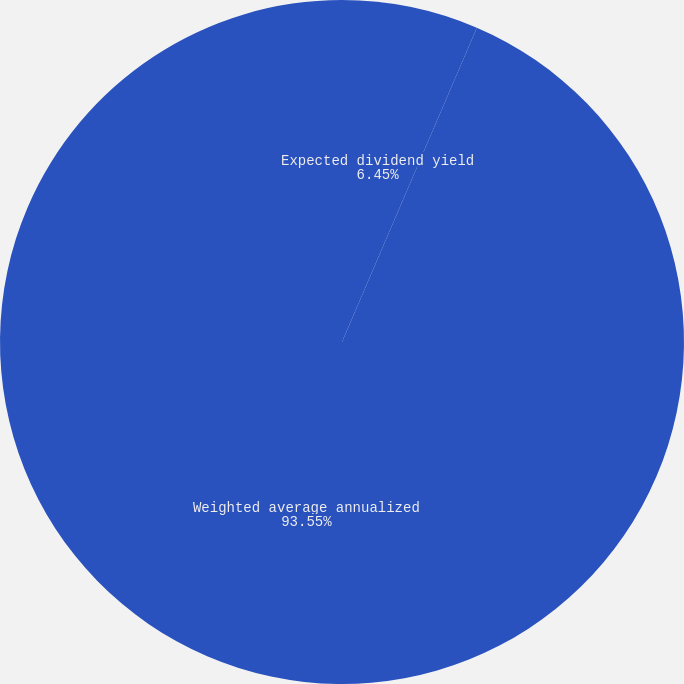Convert chart. <chart><loc_0><loc_0><loc_500><loc_500><pie_chart><fcel>Expected dividend yield<fcel>Weighted average annualized<nl><fcel>6.45%<fcel>93.55%<nl></chart> 